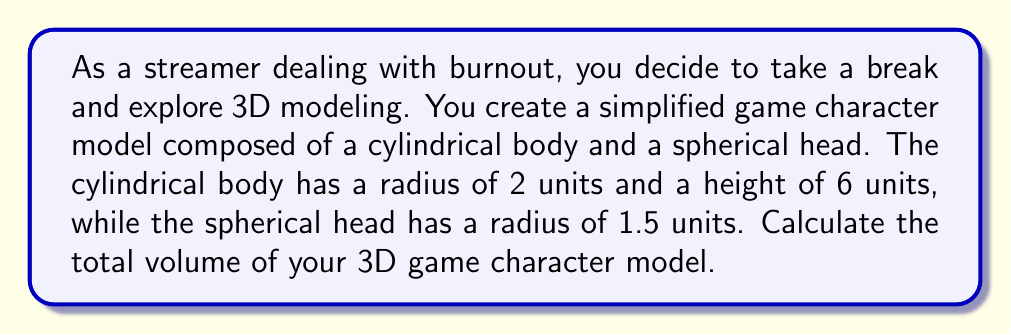Help me with this question. Let's break this problem down into steps:

1. Calculate the volume of the cylindrical body:
   The formula for the volume of a cylinder is $V_{cylinder} = \pi r^2 h$
   where $r$ is the radius and $h$ is the height.
   
   $V_{body} = \pi (2)^2 (6) = 24\pi$ cubic units

2. Calculate the volume of the spherical head:
   The formula for the volume of a sphere is $V_{sphere} = \frac{4}{3}\pi r^3$
   where $r$ is the radius.
   
   $V_{head} = \frac{4}{3}\pi (1.5)^3 = \frac{4}{3}\pi (3.375) = 4.5\pi$ cubic units

3. Sum up the volumes to get the total volume:
   $V_{total} = V_{body} + V_{head}$
   $V_{total} = 24\pi + 4.5\pi = 28.5\pi$ cubic units

To visualize the character model:

[asy]
import three;

// Draw cylindrical body
draw(cylinder((0,0,0),2,6));

// Draw spherical head
draw(shift(0,0,6)*sphere((0,0,0),1.5));

// Labels
label("Body", (2.5,0,3));
label("Head", (2,0,7.5));
[/asy]

This simplified model gives us a basic representation of a game character, combining geometric shapes to create a recognizable figure.
Answer: The total volume of the 3D game character model is $28.5\pi$ cubic units. 